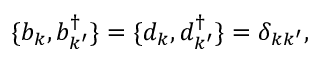<formula> <loc_0><loc_0><loc_500><loc_500>\{ b _ { k } , b _ { k ^ { \prime } } ^ { \dagger } \} = \{ d _ { k } , d _ { k ^ { \prime } } ^ { \dagger } \} = \delta _ { k k ^ { \prime } } ,</formula> 